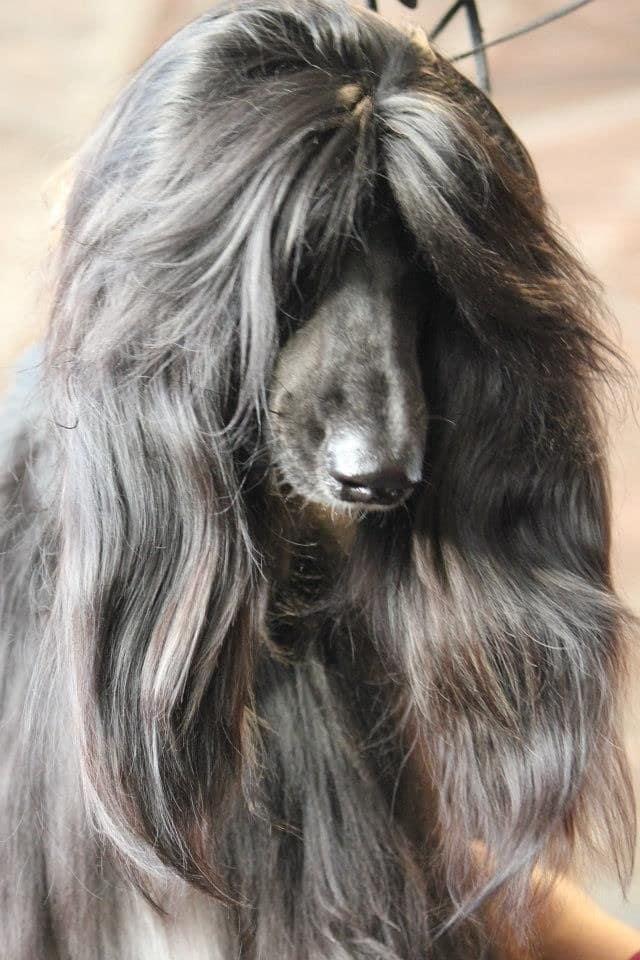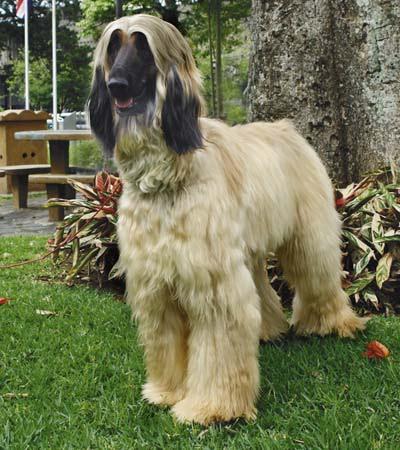The first image is the image on the left, the second image is the image on the right. For the images shown, is this caption "One of the dogs has braided hair." true? Answer yes or no. No. 